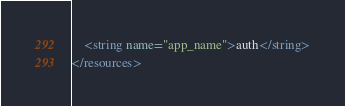<code> <loc_0><loc_0><loc_500><loc_500><_XML_>    <string name="app_name">auth</string>
</resources></code> 